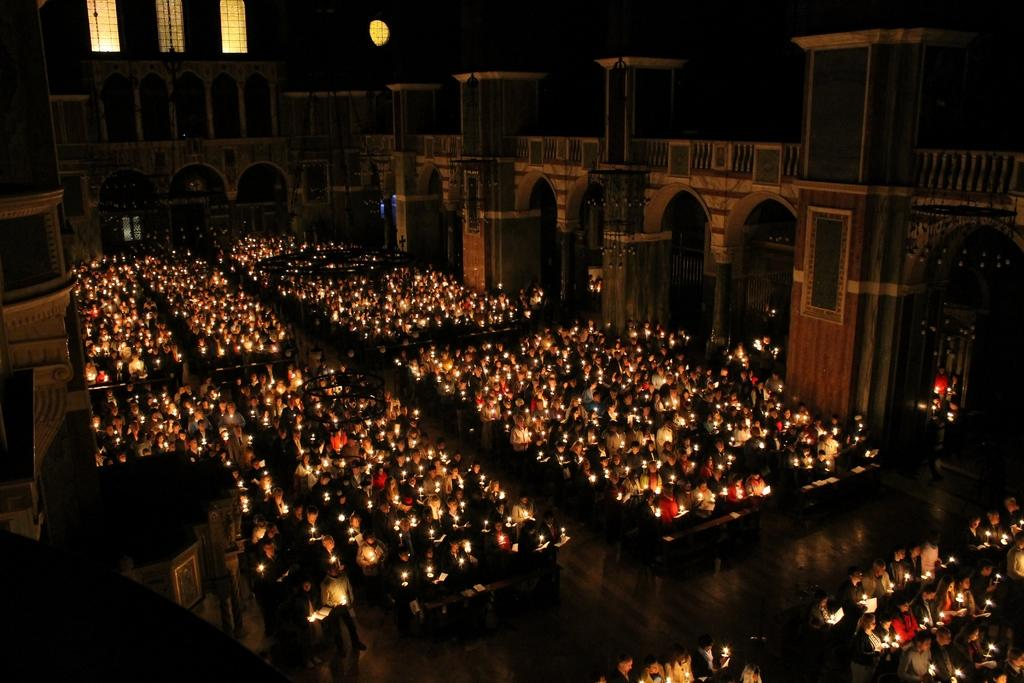What type of location is depicted in the image? The image shows the interior of a building. What part of the building is visible in the image? There is a floor visible in the image. What are the people in the image doing? The people are standing on the floor and holding candles in their hands. What is the price of the quince being sold in the image? There is no quince or any indication of a sale in the image; it shows people holding candles in a building. 